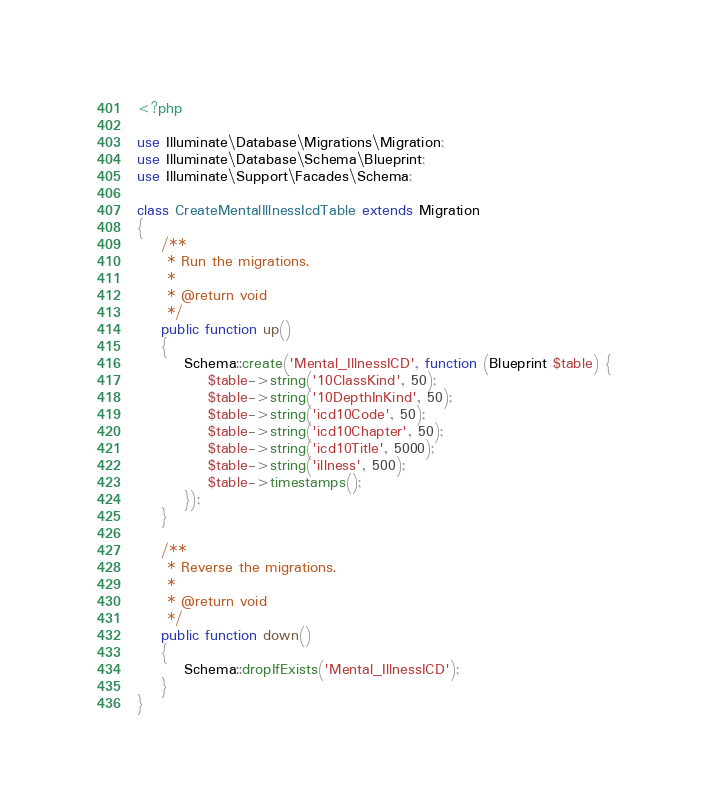Convert code to text. <code><loc_0><loc_0><loc_500><loc_500><_PHP_><?php

use Illuminate\Database\Migrations\Migration;
use Illuminate\Database\Schema\Blueprint;
use Illuminate\Support\Facades\Schema;

class CreateMentalIllnessIcdTable extends Migration
{
    /**
     * Run the migrations.
     *
     * @return void
     */
    public function up()
    {
        Schema::create('Mental_IllnessICD', function (Blueprint $table) {
            $table->string('10ClassKind', 50);
            $table->string('10DepthInKind', 50);
            $table->string('icd10Code', 50);
            $table->string('icd10Chapter', 50);
            $table->string('icd10Title', 5000);
            $table->string('illness', 500);
            $table->timestamps();
        });
    }

    /**
     * Reverse the migrations.
     *
     * @return void
     */
    public function down()
    {
        Schema::dropIfExists('Mental_IllnessICD');
    }
}
</code> 